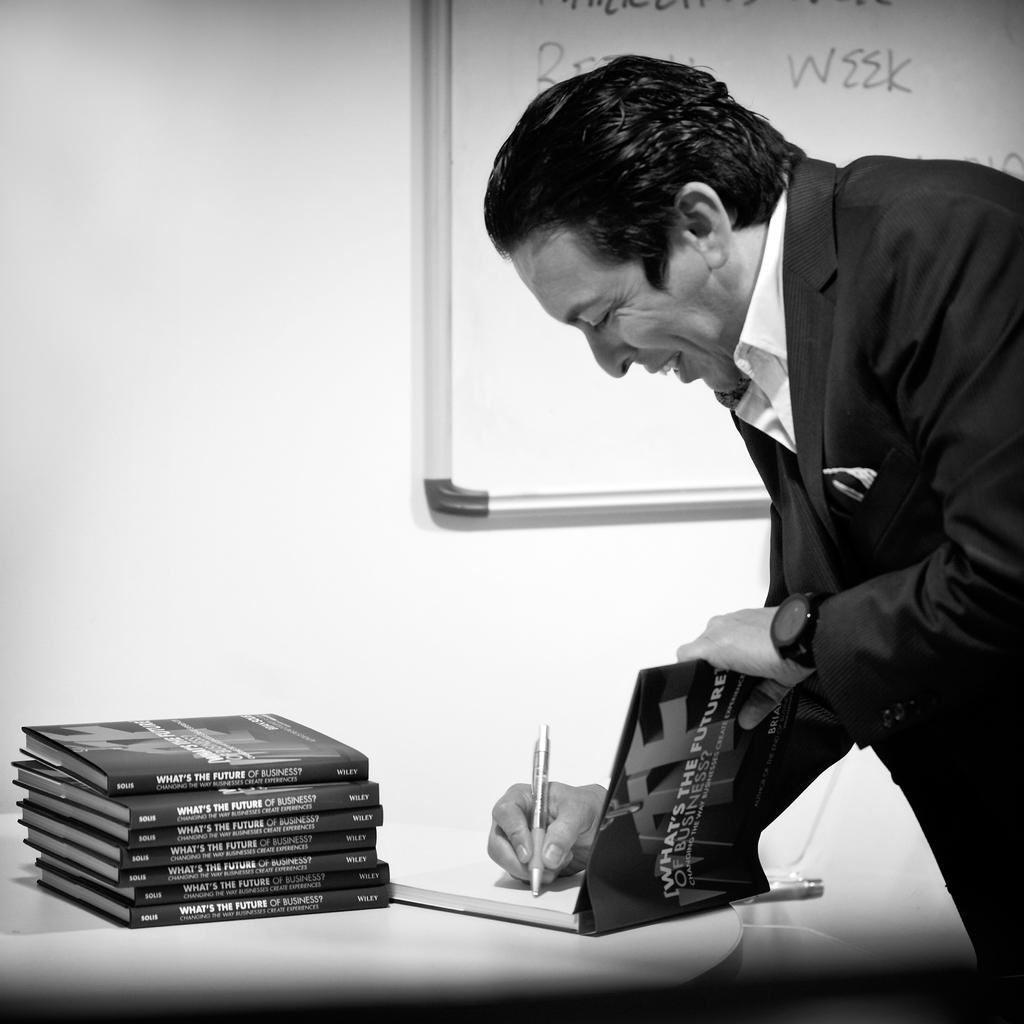<image>
Describe the image concisely. A man signs the book What's the future of business. 